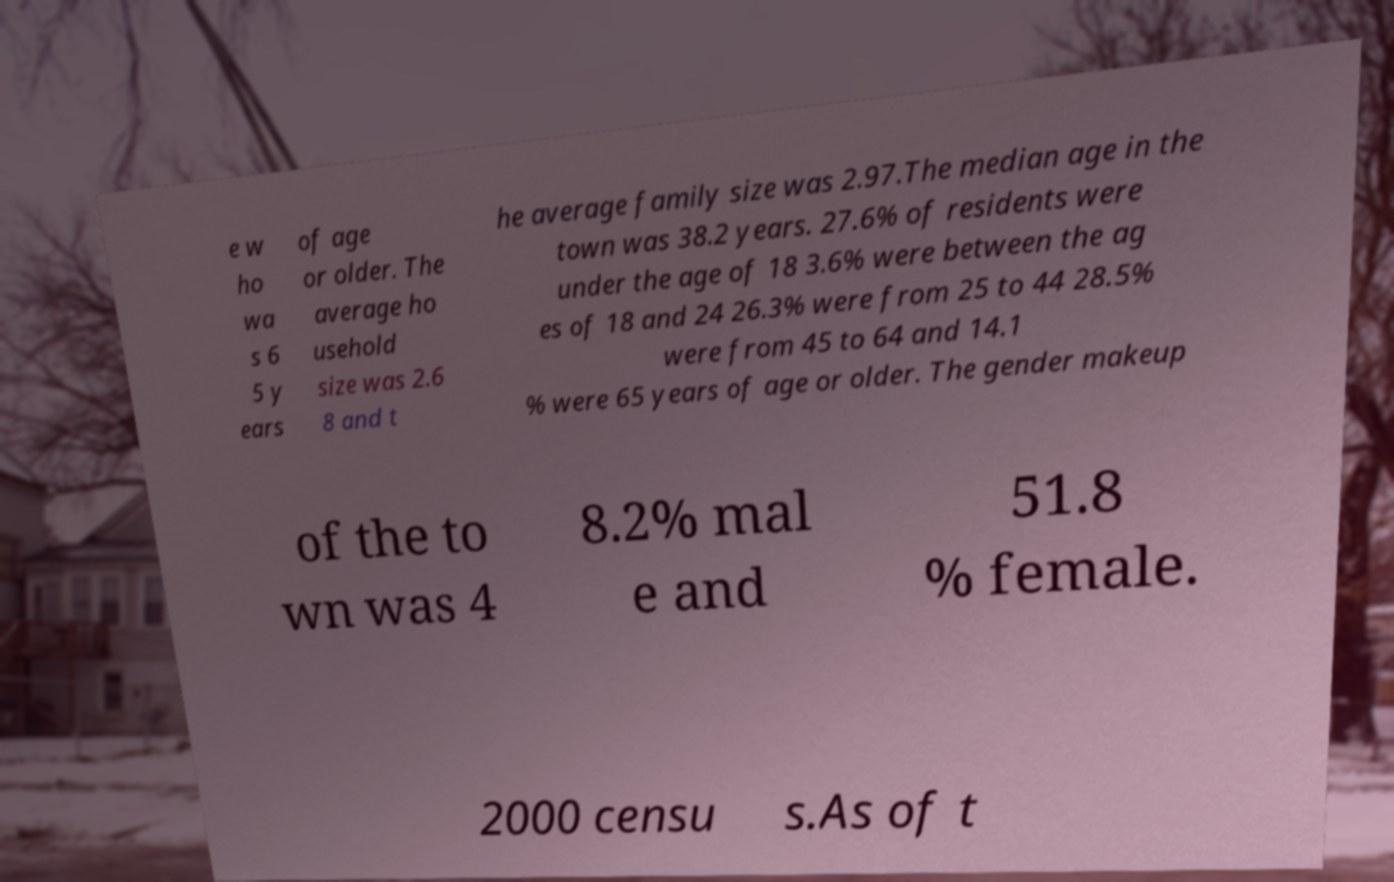Can you read and provide the text displayed in the image?This photo seems to have some interesting text. Can you extract and type it out for me? e w ho wa s 6 5 y ears of age or older. The average ho usehold size was 2.6 8 and t he average family size was 2.97.The median age in the town was 38.2 years. 27.6% of residents were under the age of 18 3.6% were between the ag es of 18 and 24 26.3% were from 25 to 44 28.5% were from 45 to 64 and 14.1 % were 65 years of age or older. The gender makeup of the to wn was 4 8.2% mal e and 51.8 % female. 2000 censu s.As of t 